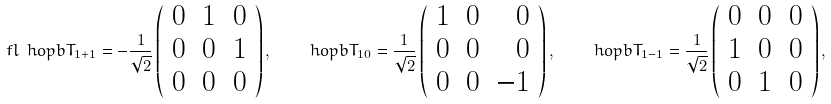Convert formula to latex. <formula><loc_0><loc_0><loc_500><loc_500>\ f l \ h o p b { T } _ { 1 + 1 } = - \frac { 1 } { \sqrt { 2 } } \left ( \begin{array} { r r r } 0 & 1 & 0 \\ 0 & 0 & 1 \\ 0 & 0 & 0 \end{array} \right ) , \quad \ h o p b { T } _ { 1 0 } = \frac { 1 } { \sqrt { 2 } } \left ( \begin{array} { r r r } 1 & 0 & 0 \\ 0 & 0 & 0 \\ 0 & 0 & - 1 \end{array} \right ) , \quad \ h o p b { T } _ { 1 - 1 } = \frac { 1 } { \sqrt { 2 } } \left ( \begin{array} { r r r } 0 & 0 & 0 \\ 1 & 0 & 0 \\ 0 & 1 & 0 \end{array} \right ) ,</formula> 